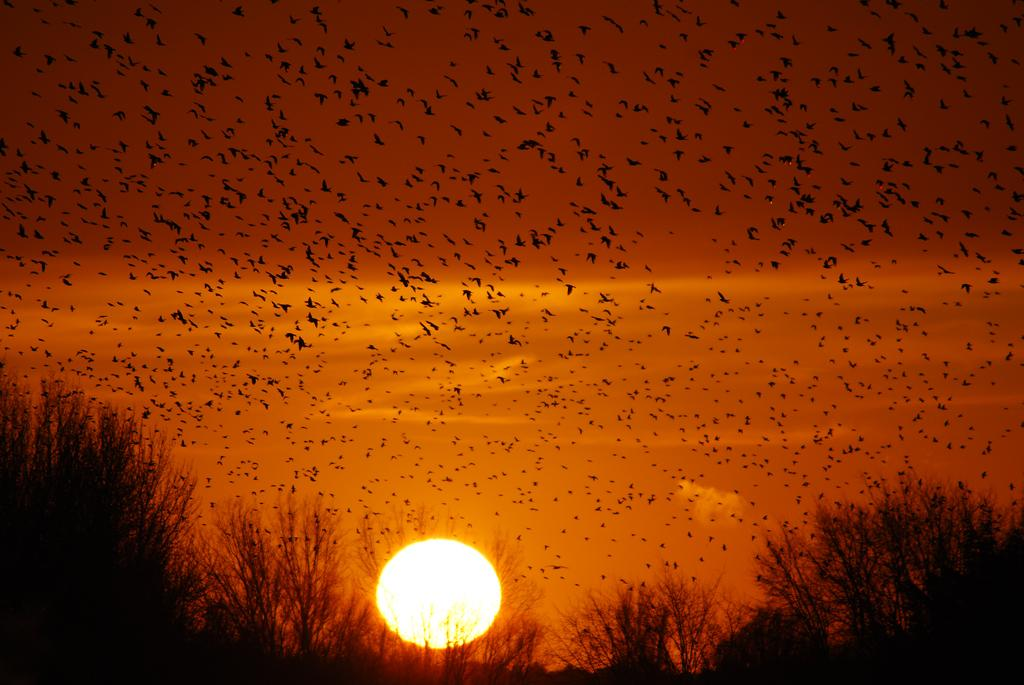What is happening in the sky in the image? There are many birds flying in the air in the image. What can be observed about the sun in the image? The sun is setting in the image. What type of ground is visible at the bottom of the image? There is grass visible at the bottom of the image. How many cars can be seen crushed under the weight of the birds in the image? There are no cars present in the image, and the birds are flying, not crushing anything. What suggestion is being made by the birds in the image? The image does not depict any suggestions being made by the birds; they are simply flying. 